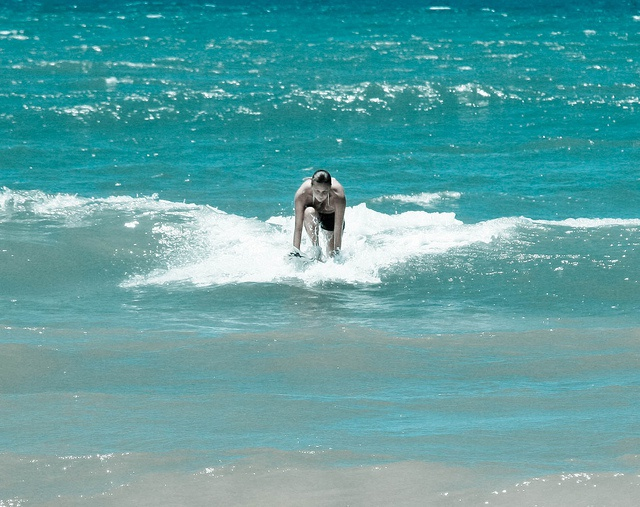Describe the objects in this image and their specific colors. I can see people in teal, gray, darkgray, white, and black tones and surfboard in teal, lightgray, lightblue, and darkgray tones in this image. 